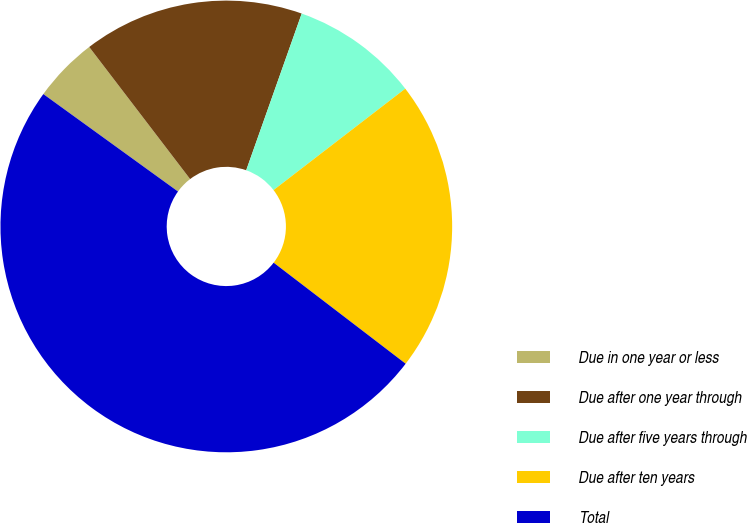<chart> <loc_0><loc_0><loc_500><loc_500><pie_chart><fcel>Due in one year or less<fcel>Due after one year through<fcel>Due after five years through<fcel>Due after ten years<fcel>Total<nl><fcel>4.65%<fcel>15.8%<fcel>9.14%<fcel>20.84%<fcel>49.57%<nl></chart> 